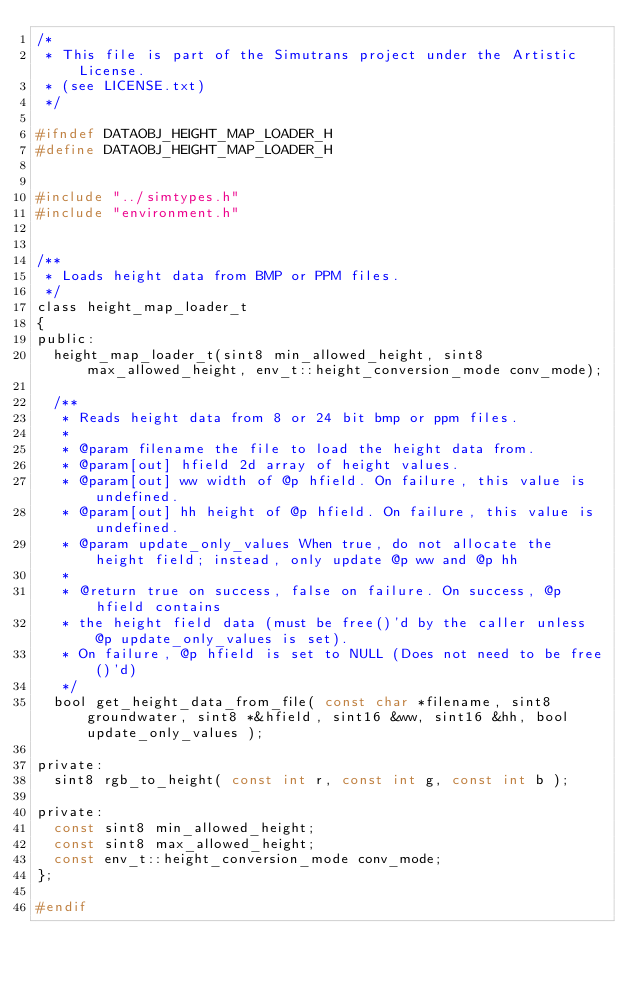Convert code to text. <code><loc_0><loc_0><loc_500><loc_500><_C_>/*
 * This file is part of the Simutrans project under the Artistic License.
 * (see LICENSE.txt)
 */

#ifndef DATAOBJ_HEIGHT_MAP_LOADER_H
#define DATAOBJ_HEIGHT_MAP_LOADER_H


#include "../simtypes.h"
#include "environment.h"


/**
 * Loads height data from BMP or PPM files.
 */
class height_map_loader_t
{
public:
	height_map_loader_t(sint8 min_allowed_height, sint8 max_allowed_height, env_t::height_conversion_mode conv_mode);

	/**
	 * Reads height data from 8 or 24 bit bmp or ppm files.
	 *
	 * @param filename the file to load the height data from.
	 * @param[out] hfield 2d array of height values.
	 * @param[out] ww width of @p hfield. On failure, this value is undefined.
	 * @param[out] hh height of @p hfield. On failure, this value is undefined.
	 * @param update_only_values When true, do not allocate the height field; instead, only update @p ww and @p hh
	 *
	 * @return true on success, false on failure. On success, @p hfield contains
	 * the height field data (must be free()'d by the caller unless @p update_only_values is set).
	 * On failure, @p hfield is set to NULL (Does not need to be free()'d)
	 */
	bool get_height_data_from_file( const char *filename, sint8 groundwater, sint8 *&hfield, sint16 &ww, sint16 &hh, bool update_only_values );

private:
	sint8 rgb_to_height( const int r, const int g, const int b );

private:
	const sint8 min_allowed_height;
	const sint8 max_allowed_height;
	const env_t::height_conversion_mode conv_mode;
};

#endif
</code> 